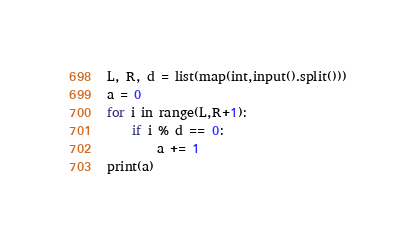<code> <loc_0><loc_0><loc_500><loc_500><_Python_>L, R, d = list(map(int,input().split()))
a = 0
for i in range(L,R+1):
    if i % d == 0:
        a += 1
print(a)</code> 